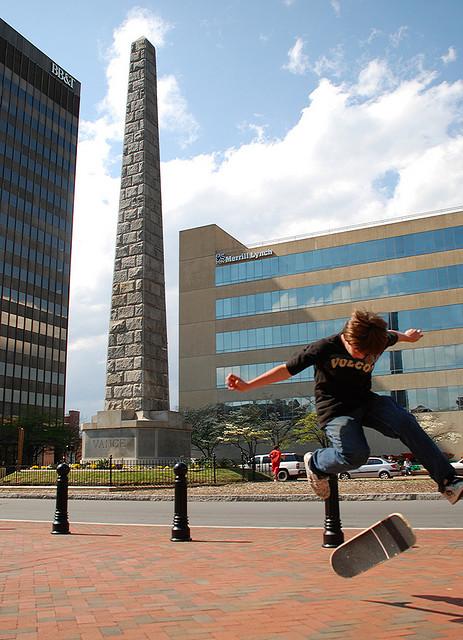What is the monument in the background?
Answer briefly. Washington. What is the boy doing?
Give a very brief answer. Skateboarding. How is the weather in this scene?
Concise answer only. Sunny. 